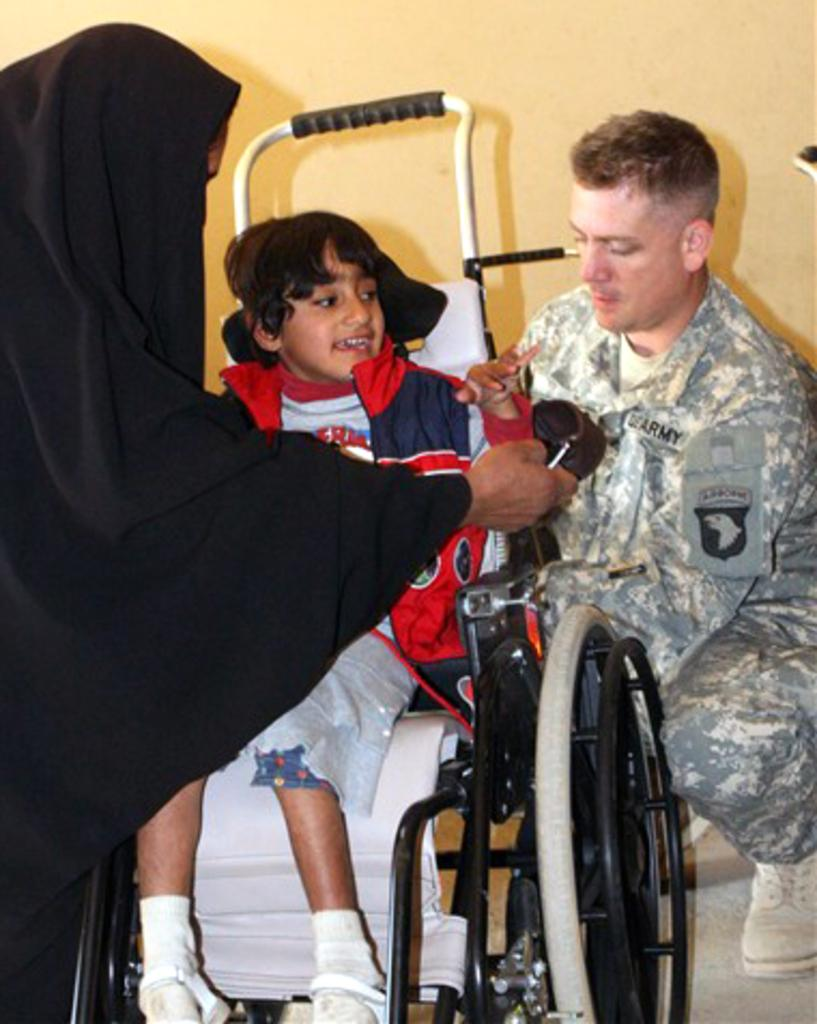Who is behind the wheelchair in the image? There is a person behind the wheelchair in the image. What is the position of the boy in the image? A boy is sitting in the wheelchair. Can you describe the woman's appearance in the image? There is a woman wearing a black dress on the left side of the image. What can be seen in the background of the image? There is a wall in the background of the image. What type of joke is the boy telling in the image? There is no indication in the image that the boy is telling a joke, as the focus is on his position in the wheelchair and the presence of the person behind him. --- Facts: 1. There is a person holding a camera in the image. 2. The person is standing on a bridge. 3. There is a river below the bridge. 4. The sky is visible in the image. Absurd Topics: cake, parrot, ladder Conversation: What is the person in the image holding? The person in the image is holding a camera. Where is the person standing in the image? The person is standing on a bridge. What can be seen below the bridge in the image? There is a river below the bridge. What is visible in the background of the image? The sky is visible in the image. Reasoning: Let's think step by step in order to produce the conversation. We start by identifying the main subject in the image, which is the person holding a camera. Then, we expand the conversation to include other details about the person's location and the surrounding environment, such as the bridge, the river, and the sky. Each question is designed to elicit a specific detail about the image that is known from the provided facts. Absurd Question/Answer: What type of cake is being served on the ladder in the image? There is no cake or ladder present in the image; the focus is on the person holding a camera on a bridge with a river below and the sky visible in the background. 